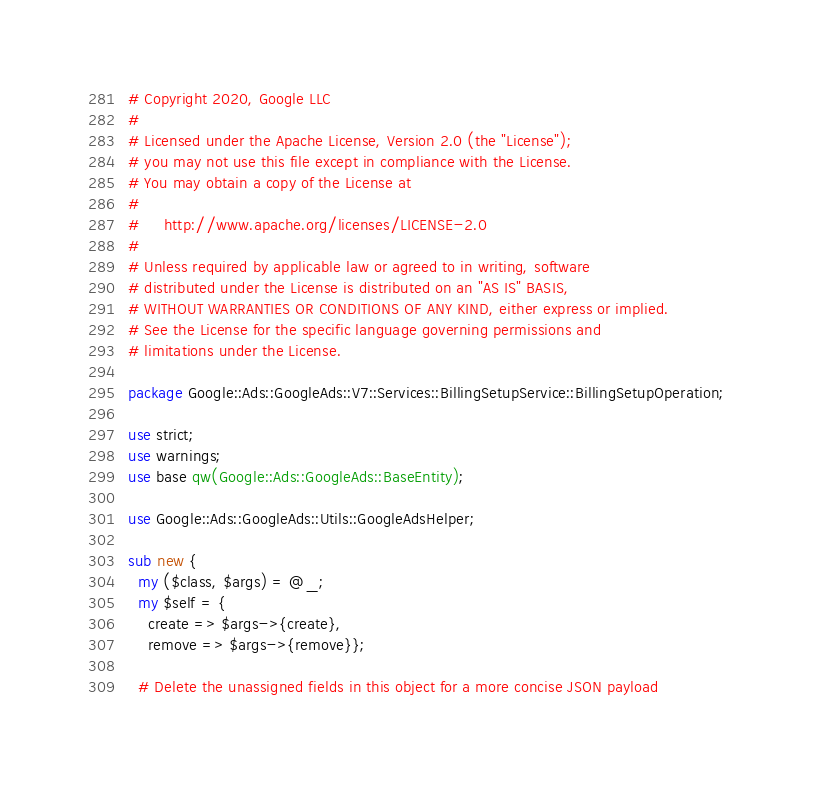Convert code to text. <code><loc_0><loc_0><loc_500><loc_500><_Perl_># Copyright 2020, Google LLC
#
# Licensed under the Apache License, Version 2.0 (the "License");
# you may not use this file except in compliance with the License.
# You may obtain a copy of the License at
#
#     http://www.apache.org/licenses/LICENSE-2.0
#
# Unless required by applicable law or agreed to in writing, software
# distributed under the License is distributed on an "AS IS" BASIS,
# WITHOUT WARRANTIES OR CONDITIONS OF ANY KIND, either express or implied.
# See the License for the specific language governing permissions and
# limitations under the License.

package Google::Ads::GoogleAds::V7::Services::BillingSetupService::BillingSetupOperation;

use strict;
use warnings;
use base qw(Google::Ads::GoogleAds::BaseEntity);

use Google::Ads::GoogleAds::Utils::GoogleAdsHelper;

sub new {
  my ($class, $args) = @_;
  my $self = {
    create => $args->{create},
    remove => $args->{remove}};

  # Delete the unassigned fields in this object for a more concise JSON payload</code> 